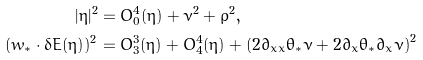<formula> <loc_0><loc_0><loc_500><loc_500>| \eta | ^ { 2 } & = O _ { 0 } ^ { 4 } ( \eta ) + \nu ^ { 2 } + \rho ^ { 2 } , \\ ( w _ { * } \cdot \delta E ( \eta ) ) ^ { 2 } & = O ^ { 3 } _ { 3 } ( \eta ) + O _ { 4 } ^ { 4 } ( \eta ) + \left ( 2 \partial _ { x x } \theta _ { * } \nu + 2 \partial _ { x } \theta _ { * } \partial _ { x } \nu \right ) ^ { 2 }</formula> 